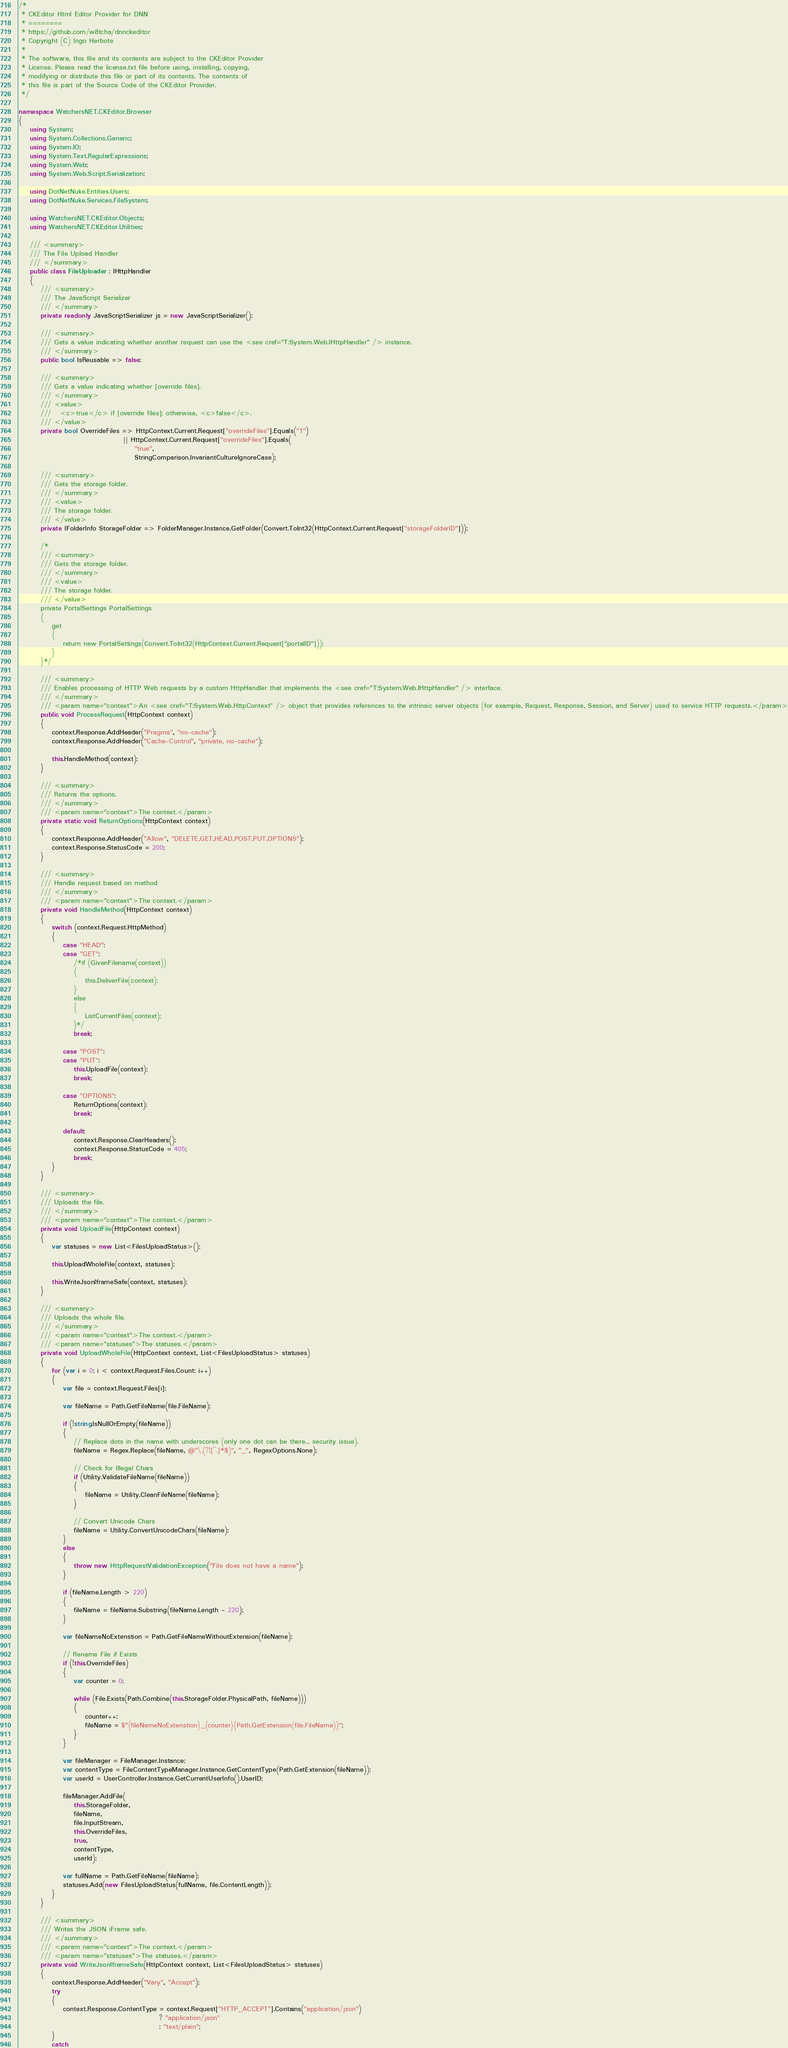<code> <loc_0><loc_0><loc_500><loc_500><_C#_>/*
 * CKEditor Html Editor Provider for DNN
 * ========
 * https://github.com/w8tcha/dnnckeditor
 * Copyright (C) Ingo Herbote
 *
 * The software, this file and its contents are subject to the CKEditor Provider
 * License. Please read the license.txt file before using, installing, copying,
 * modifying or distribute this file or part of its contents. The contents of
 * this file is part of the Source Code of the CKEditor Provider.
 */

namespace WatchersNET.CKEditor.Browser
{
    using System;
    using System.Collections.Generic;
    using System.IO;
    using System.Text.RegularExpressions;
    using System.Web;
    using System.Web.Script.Serialization;

    using DotNetNuke.Entities.Users;
    using DotNetNuke.Services.FileSystem;

    using WatchersNET.CKEditor.Objects;
    using WatchersNET.CKEditor.Utilities;

    /// <summary>
    /// The File Upload Handler
    /// </summary>
    public class FileUploader : IHttpHandler
    {
        /// <summary>
        /// The JavaScript Serializer
        /// </summary>
        private readonly JavaScriptSerializer js = new JavaScriptSerializer();

        /// <summary>
        /// Gets a value indicating whether another request can use the <see cref="T:System.Web.IHttpHandler" /> instance.
        /// </summary>
        public bool IsReusable => false;

        /// <summary>
        /// Gets a value indicating whether [override files].
        /// </summary>
        /// <value>
        ///   <c>true</c> if [override files]; otherwise, <c>false</c>.
        /// </value>
        private bool OverrideFiles => HttpContext.Current.Request["overrideFiles"].Equals("1")
                                      || HttpContext.Current.Request["overrideFiles"].Equals(
                                          "true",
                                          StringComparison.InvariantCultureIgnoreCase);

        /// <summary>
        /// Gets the storage folder.
        /// </summary>
        /// <value>
        /// The storage folder.
        /// </value>
        private IFolderInfo StorageFolder => FolderManager.Instance.GetFolder(Convert.ToInt32(HttpContext.Current.Request["storageFolderID"]));

        /*
        /// <summary>
        /// Gets the storage folder.
        /// </summary>
        /// <value>
        /// The storage folder.
        /// </value>
        private PortalSettings PortalSettings
        {
            get
            {
                return new PortalSettings(Convert.ToInt32(HttpContext.Current.Request["portalID"]));
            }
        }*/

        /// <summary>
        /// Enables processing of HTTP Web requests by a custom HttpHandler that implements the <see cref="T:System.Web.IHttpHandler" /> interface.
        /// </summary>
        /// <param name="context">An <see cref="T:System.Web.HttpContext" /> object that provides references to the intrinsic server objects (for example, Request, Response, Session, and Server) used to service HTTP requests.</param>
        public void ProcessRequest(HttpContext context)
        {
            context.Response.AddHeader("Pragma", "no-cache");
            context.Response.AddHeader("Cache-Control", "private, no-cache");

            this.HandleMethod(context);
        }

        /// <summary>
        /// Returns the options.
        /// </summary>
        /// <param name="context">The context.</param>
        private static void ReturnOptions(HttpContext context)
        {
            context.Response.AddHeader("Allow", "DELETE,GET,HEAD,POST,PUT,OPTIONS");
            context.Response.StatusCode = 200;
        }

        /// <summary>
        /// Handle request based on method
        /// </summary>
        /// <param name="context">The context.</param>
        private void HandleMethod(HttpContext context)
        {
            switch (context.Request.HttpMethod)
            {
                case "HEAD":
                case "GET":
                    /*if (GivenFilename(context))
                    {
                        this.DeliverFile(context);
                    }
                    else
                    {
                        ListCurrentFiles(context);
                    }*/
                    break;

                case "POST":
                case "PUT":
                    this.UploadFile(context);
                    break;

                case "OPTIONS":
                    ReturnOptions(context);
                    break;

                default:
                    context.Response.ClearHeaders();
                    context.Response.StatusCode = 405;
                    break;
            }
        }

        /// <summary>
        /// Uploads the file.
        /// </summary>
        /// <param name="context">The context.</param>
        private void UploadFile(HttpContext context)
        {
            var statuses = new List<FilesUploadStatus>();

            this.UploadWholeFile(context, statuses);

            this.WriteJsonIframeSafe(context, statuses);
        }

        /// <summary>
        /// Uploads the whole file.
        /// </summary>
        /// <param name="context">The context.</param>
        /// <param name="statuses">The statuses.</param>
        private void UploadWholeFile(HttpContext context, List<FilesUploadStatus> statuses)
        {
            for (var i = 0; i < context.Request.Files.Count; i++)
            {
                var file = context.Request.Files[i];

                var fileName = Path.GetFileName(file.FileName);

                if (!string.IsNullOrEmpty(fileName))
                {
                    // Replace dots in the name with underscores (only one dot can be there... security issue).
                    fileName = Regex.Replace(fileName, @"\.(?![^.]*$)", "_", RegexOptions.None);

                    // Check for Illegal Chars
                    if (Utility.ValidateFileName(fileName))
                    {
                        fileName = Utility.CleanFileName(fileName);
                    }

                    // Convert Unicode Chars
                    fileName = Utility.ConvertUnicodeChars(fileName);
                }
                else
                {
                    throw new HttpRequestValidationException("File does not have a name");
                }

                if (fileName.Length > 220)
                {
                    fileName = fileName.Substring(fileName.Length - 220);
                }

                var fileNameNoExtenstion = Path.GetFileNameWithoutExtension(fileName);

                // Rename File if Exists
                if (!this.OverrideFiles)
                {
                    var counter = 0;

                    while (File.Exists(Path.Combine(this.StorageFolder.PhysicalPath, fileName)))
                    {
                        counter++;
                        fileName = $"{fileNameNoExtenstion}_{counter}{Path.GetExtension(file.FileName)}";
                    }
                }

                var fileManager = FileManager.Instance;
                var contentType = FileContentTypeManager.Instance.GetContentType(Path.GetExtension(fileName));
                var userId = UserController.Instance.GetCurrentUserInfo().UserID;

                fileManager.AddFile(
                    this.StorageFolder,
                    fileName,
                    file.InputStream,
                    this.OverrideFiles,
                    true,
                    contentType,
                    userId);

                var fullName = Path.GetFileName(fileName);
                statuses.Add(new FilesUploadStatus(fullName, file.ContentLength));
            }
        }

        /// <summary>
        /// Writes the JSON iFrame safe.
        /// </summary>
        /// <param name="context">The context.</param>
        /// <param name="statuses">The statuses.</param>
        private void WriteJsonIframeSafe(HttpContext context, List<FilesUploadStatus> statuses)
        {
            context.Response.AddHeader("Vary", "Accept");
            try
            {
                context.Response.ContentType = context.Request["HTTP_ACCEPT"].Contains("application/json")
                                                   ? "application/json"
                                                   : "text/plain";
            }
            catch</code> 